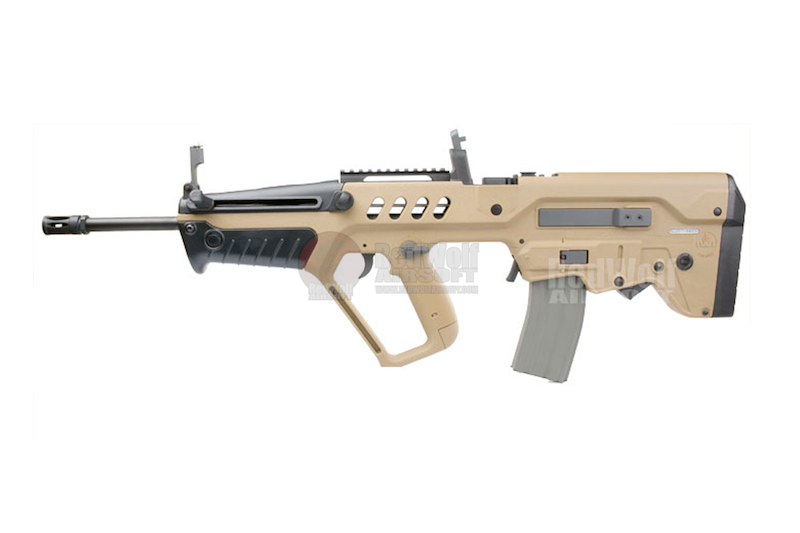What makes the design of this firearm unique compared to conventional rifles? The firearm's bullpup design is particularly unique compared to conventional rifles. By incorporating the action and magazine behind the trigger, the overall length of the weapon is reduced without compromising the barrel length. This results in better maneuverability and balance. Additionally, the integrated Picatinny rail allows for versatile customization options, supporting a wide array of optics and accessories. The ergonomic pistol grip and foregrip enhance handling and control, making it user-friendly. These features combine to create a compact yet highly accurate firearm. 